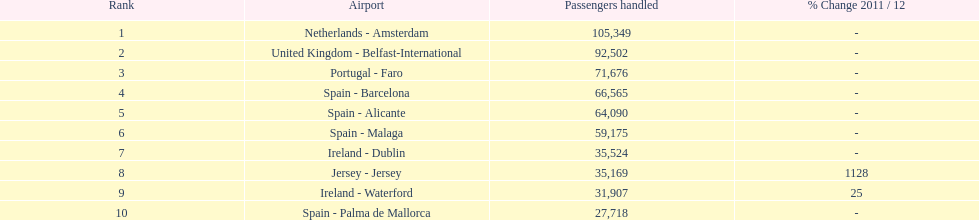Which airport had more passengers handled than the united kingdom? Netherlands - Amsterdam. 